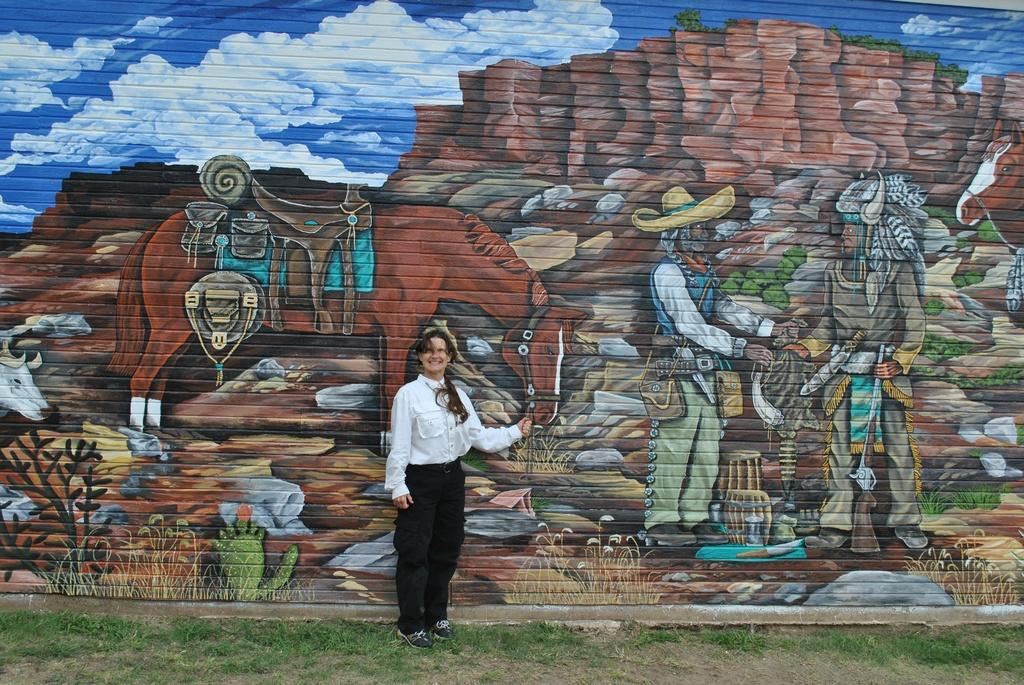Who is the main subject in the image? There is a lady standing in the image. What is the lady standing on? The lady is standing on the ground. What type of vegetation is present on the ground? The ground has grass on it. What can be seen on the wall in the image? There is a wall with some art in the image. What type of trade is happening in the image? There is no trade happening in the image; it features a lady standing on grassy ground with a wall and some art. Is there any snow visible in the image? No, there is no snow present in the image; the ground has grass on it. 